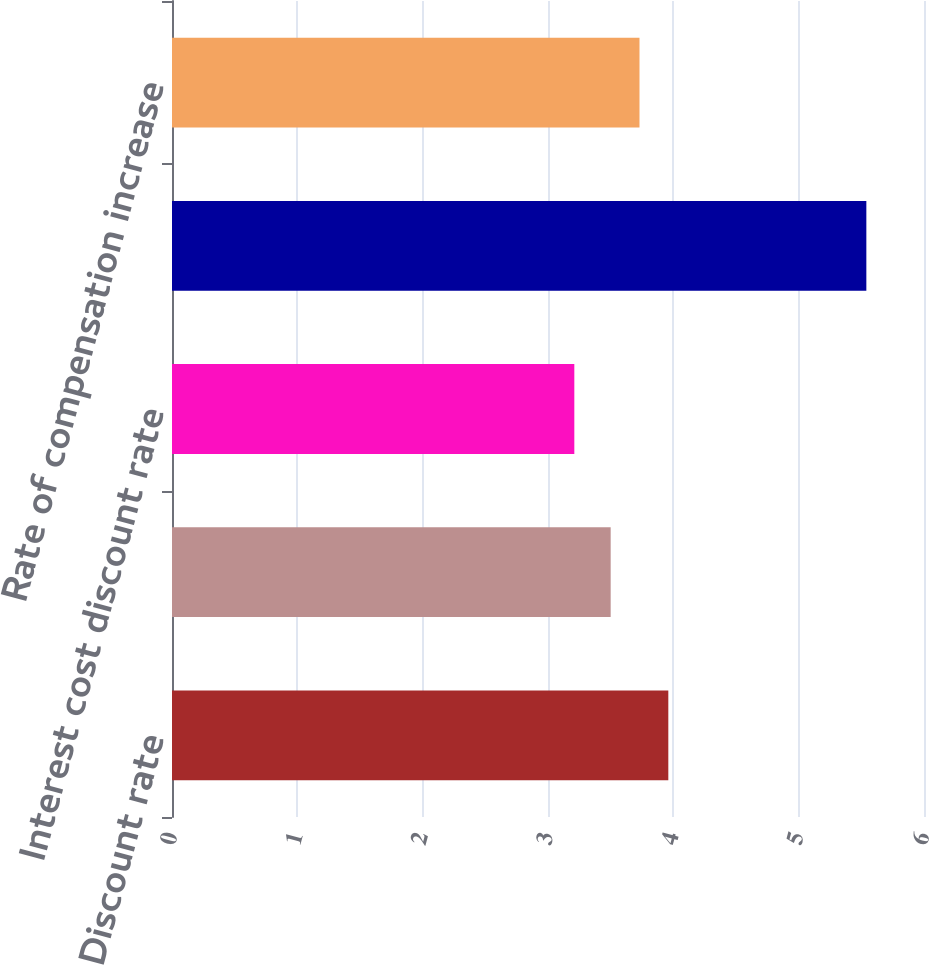<chart> <loc_0><loc_0><loc_500><loc_500><bar_chart><fcel>Discount rate<fcel>Service cost discount rate (a)<fcel>Interest cost discount rate<fcel>Expected return on plan assets<fcel>Rate of compensation increase<nl><fcel>3.96<fcel>3.5<fcel>3.21<fcel>5.54<fcel>3.73<nl></chart> 